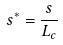Convert formula to latex. <formula><loc_0><loc_0><loc_500><loc_500>s ^ { * } = \frac { s } { L _ { c } }</formula> 